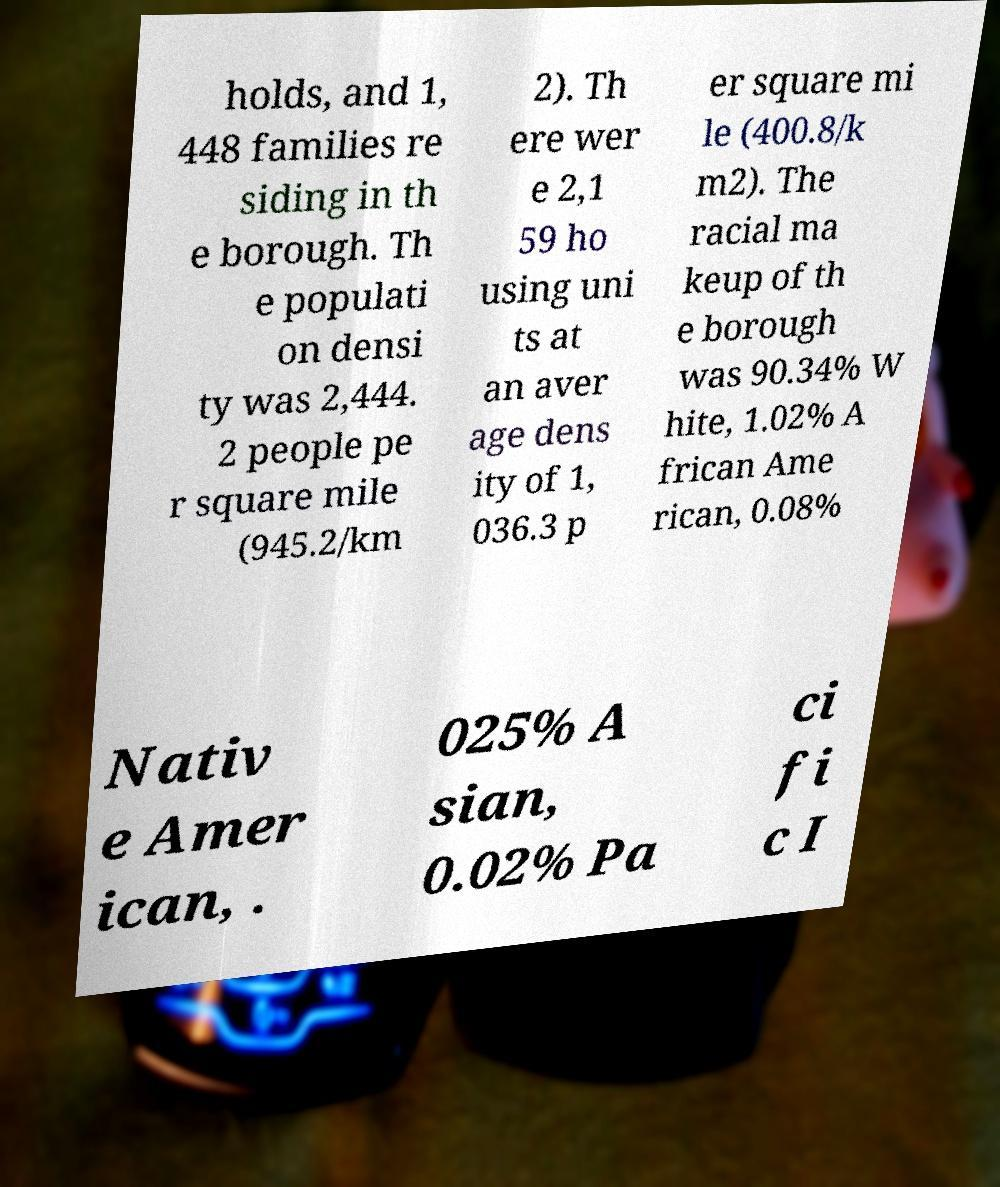I need the written content from this picture converted into text. Can you do that? holds, and 1, 448 families re siding in th e borough. Th e populati on densi ty was 2,444. 2 people pe r square mile (945.2/km 2). Th ere wer e 2,1 59 ho using uni ts at an aver age dens ity of 1, 036.3 p er square mi le (400.8/k m2). The racial ma keup of th e borough was 90.34% W hite, 1.02% A frican Ame rican, 0.08% Nativ e Amer ican, . 025% A sian, 0.02% Pa ci fi c I 